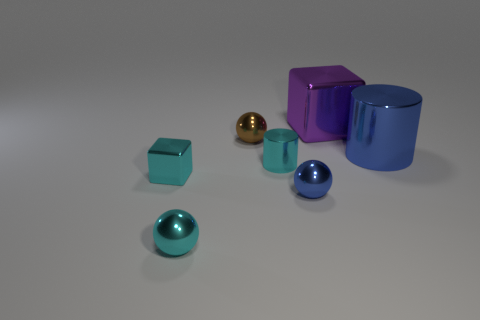Are there the same number of small brown shiny balls that are right of the small brown metal object and big things in front of the tiny cyan shiny cube?
Offer a very short reply. Yes. There is another metallic object that is the same shape as the purple object; what is its color?
Keep it short and to the point. Cyan. What number of metallic things are the same color as the tiny cube?
Ensure brevity in your answer.  2. There is a object left of the tiny cyan metal sphere; is it the same shape as the purple thing?
Your response must be concise. Yes. There is a tiny shiny thing behind the blue thing that is behind the tiny cyan object that is right of the tiny brown sphere; what is its shape?
Make the answer very short. Sphere. What size is the blue shiny cylinder?
Ensure brevity in your answer.  Large. What is the color of the big cube that is made of the same material as the small cyan ball?
Keep it short and to the point. Purple. What number of green objects have the same material as the cyan cylinder?
Your response must be concise. 0. There is a big cylinder; is it the same color as the cylinder in front of the blue metal cylinder?
Make the answer very short. No. There is a object that is right of the big metallic object that is left of the blue cylinder; what color is it?
Your answer should be very brief. Blue. 